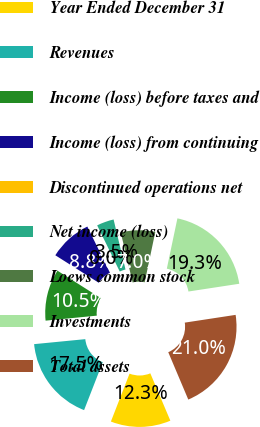Convert chart. <chart><loc_0><loc_0><loc_500><loc_500><pie_chart><fcel>Year Ended December 31<fcel>Revenues<fcel>Income (loss) before taxes and<fcel>Income (loss) from continuing<fcel>Discontinued operations net<fcel>Net income (loss)<fcel>Loews common stock<fcel>Investments<fcel>Total assets<nl><fcel>12.28%<fcel>17.54%<fcel>10.53%<fcel>8.77%<fcel>0.01%<fcel>3.52%<fcel>7.02%<fcel>19.29%<fcel>21.04%<nl></chart> 